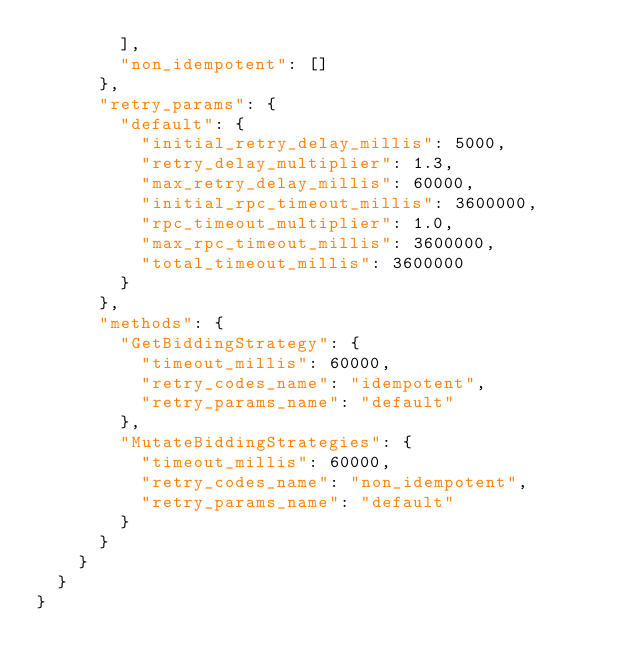Convert code to text. <code><loc_0><loc_0><loc_500><loc_500><_Python_>        ],
        "non_idempotent": []
      },
      "retry_params": {
        "default": {
          "initial_retry_delay_millis": 5000,
          "retry_delay_multiplier": 1.3,
          "max_retry_delay_millis": 60000,
          "initial_rpc_timeout_millis": 3600000,
          "rpc_timeout_multiplier": 1.0,
          "max_rpc_timeout_millis": 3600000,
          "total_timeout_millis": 3600000
        }
      },
      "methods": {
        "GetBiddingStrategy": {
          "timeout_millis": 60000,
          "retry_codes_name": "idempotent",
          "retry_params_name": "default"
        },
        "MutateBiddingStrategies": {
          "timeout_millis": 60000,
          "retry_codes_name": "non_idempotent",
          "retry_params_name": "default"
        }
      }
    }
  }
}
</code> 